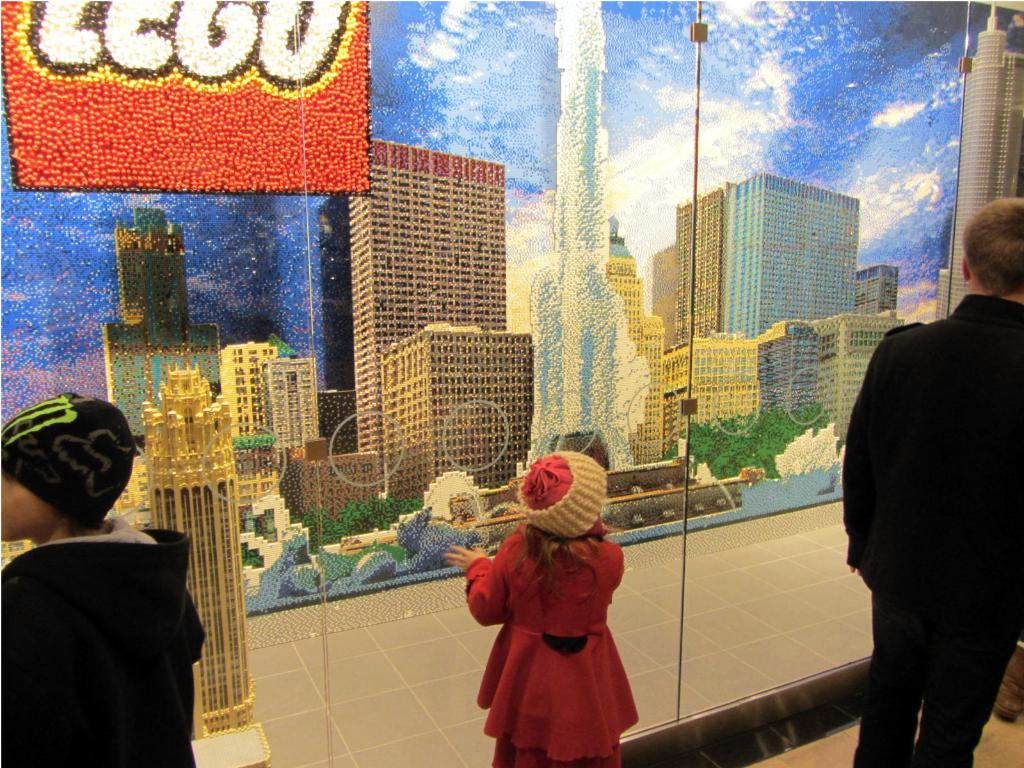What are the people in the image doing? The people in the image are standing beside a glass wall. What is depicted on the glass wall? There is a painting of buildings on the glass wall. What type of position does the church hold in the image? There is no church present in the image. Is the library visible in the image? There is no library visible in the image. 